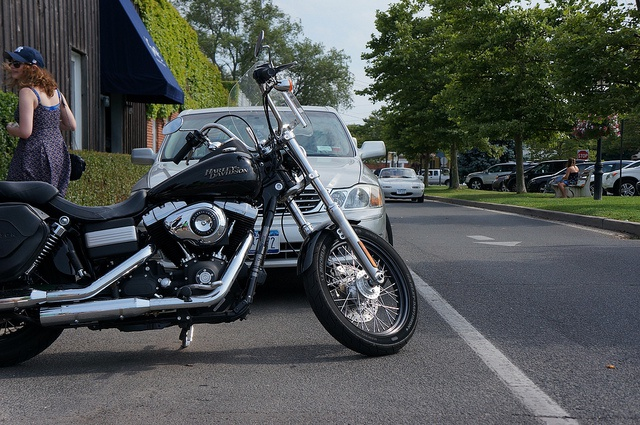Describe the objects in this image and their specific colors. I can see motorcycle in black, gray, and darkgray tones, car in black, darkgray, lightgray, and gray tones, people in black, gray, navy, and maroon tones, car in black, darkgray, and gray tones, and car in black, gray, and darkgray tones in this image. 